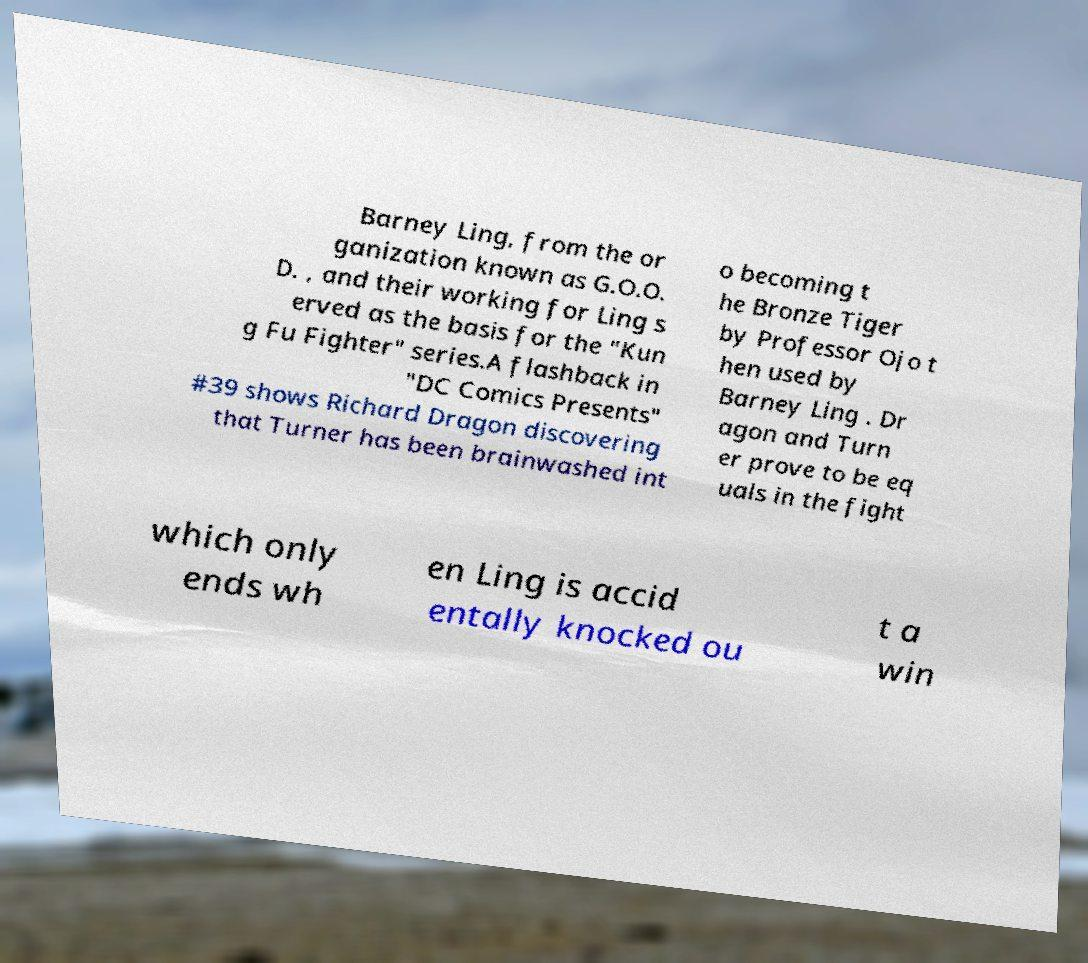There's text embedded in this image that I need extracted. Can you transcribe it verbatim? Barney Ling, from the or ganization known as G.O.O. D. , and their working for Ling s erved as the basis for the "Kun g Fu Fighter" series.A flashback in "DC Comics Presents" #39 shows Richard Dragon discovering that Turner has been brainwashed int o becoming t he Bronze Tiger by Professor Ojo t hen used by Barney Ling . Dr agon and Turn er prove to be eq uals in the fight which only ends wh en Ling is accid entally knocked ou t a win 